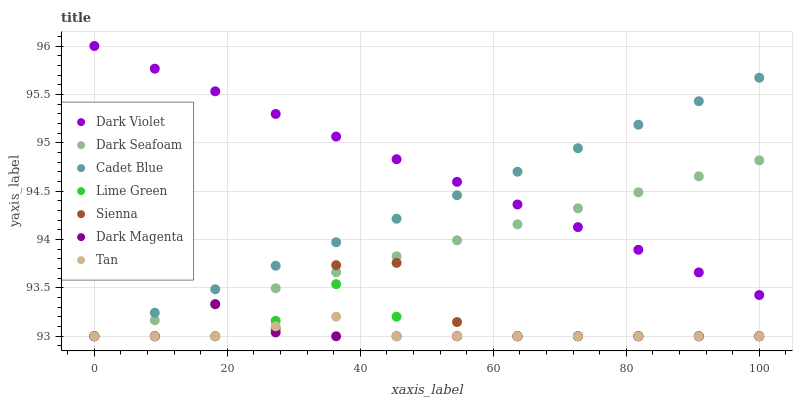Does Tan have the minimum area under the curve?
Answer yes or no. Yes. Does Dark Violet have the maximum area under the curve?
Answer yes or no. Yes. Does Dark Magenta have the minimum area under the curve?
Answer yes or no. No. Does Dark Magenta have the maximum area under the curve?
Answer yes or no. No. Is Cadet Blue the smoothest?
Answer yes or no. Yes. Is Sienna the roughest?
Answer yes or no. Yes. Is Dark Magenta the smoothest?
Answer yes or no. No. Is Dark Magenta the roughest?
Answer yes or no. No. Does Cadet Blue have the lowest value?
Answer yes or no. Yes. Does Dark Violet have the lowest value?
Answer yes or no. No. Does Dark Violet have the highest value?
Answer yes or no. Yes. Does Dark Magenta have the highest value?
Answer yes or no. No. Is Lime Green less than Dark Violet?
Answer yes or no. Yes. Is Dark Violet greater than Tan?
Answer yes or no. Yes. Does Cadet Blue intersect Tan?
Answer yes or no. Yes. Is Cadet Blue less than Tan?
Answer yes or no. No. Is Cadet Blue greater than Tan?
Answer yes or no. No. Does Lime Green intersect Dark Violet?
Answer yes or no. No. 